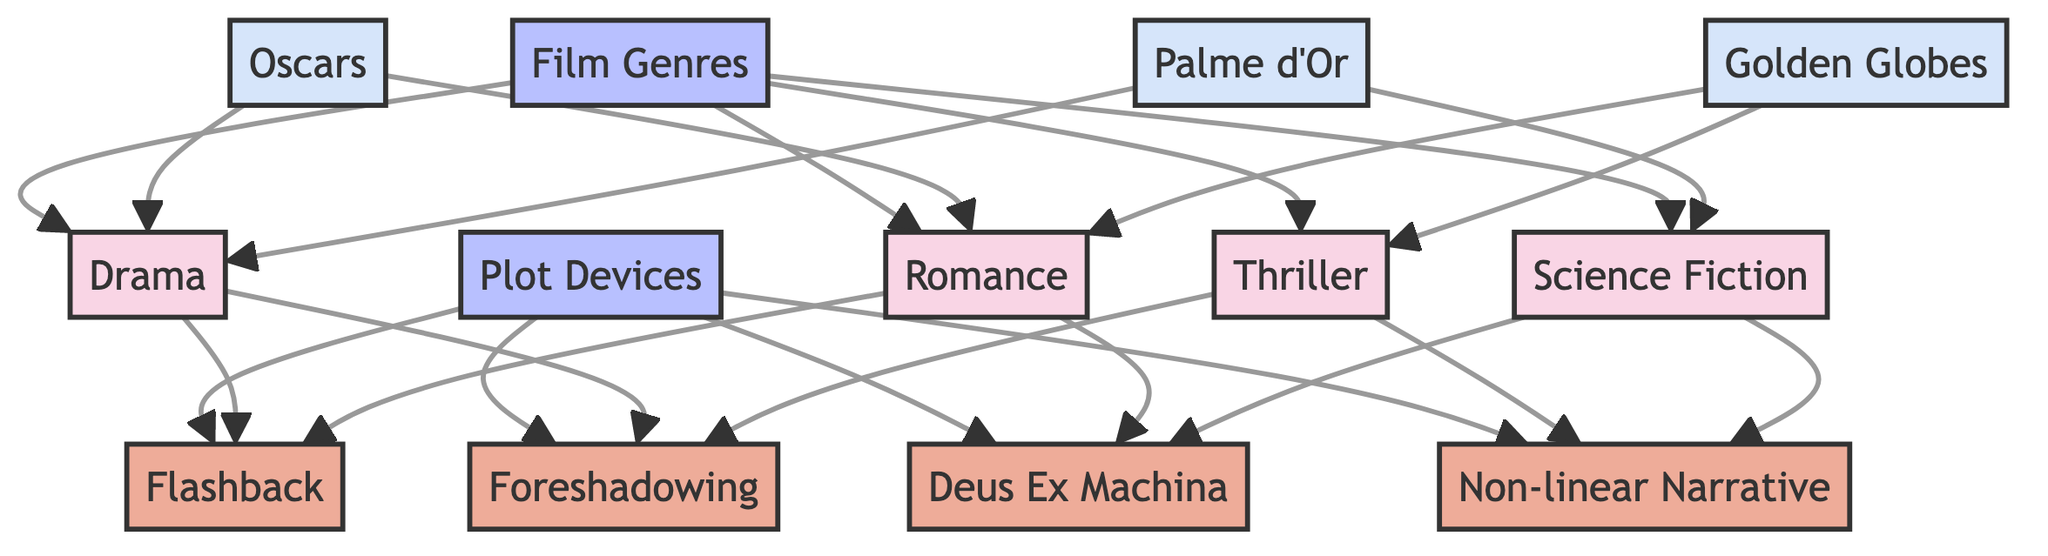What are the four main film genres depicted in the diagram? The diagram lists four nodes under "Film Genres": Drama, Romance, Thriller, and Science Fiction.
Answer: Drama, Romance, Thriller, Science Fiction How many plot devices are shown in the diagram? The diagram includes four nodes under "Plot Devices": Flashback, Deus Ex Machina, Foreshadowing, and Non-linear Narrative. Therefore, there are four plot devices in total.
Answer: Four Which film genre is directly connected to both Flashback and Foreshadowing? The nodes for Drama show direct connections to both Flashback and Foreshadowing. By following the edges from the "Film Genres" category to the "Drama" node, we see these connections.
Answer: Drama What awards are linked to the Romance genre? The diagram shows that the Romance genre is connected to both the Oscars and the Golden Globes. By checking the edges, we can see these direct connections.
Answer: Oscars, Golden Globes Which plot device is associated with both Science Fiction and Thriller? The diagram states that Deus Ex Machina and Non-linear Narrative are both connected to the Science Fiction genre and the Non-linear Narrative is also connected to Thriller. Therefore, both are associated.
Answer: Deus Ex Machina, Non-linear Narrative How many connections does the Thriller genre have? Following the edges from the Thriller node, there are two connections: one to Foreshadowing and the other to Non-linear Narrative. Thus, the total number of connections for Thriller is two.
Answer: Two Which award is linked to Science Fiction? By examining the edges, we can see that Science Fiction is connected to the Palme d'Or. This indicates that it has been recognized with this award in the context of the diagram.
Answer: Palme d'Or How many total nodes are there in the diagram? The diagram consists of a total of 14 nodes: 4 in Film Genres, 4 in Plot Devices, and 6 in the award categories. Adding these gives a total of 14 nodes.
Answer: Fourteen 